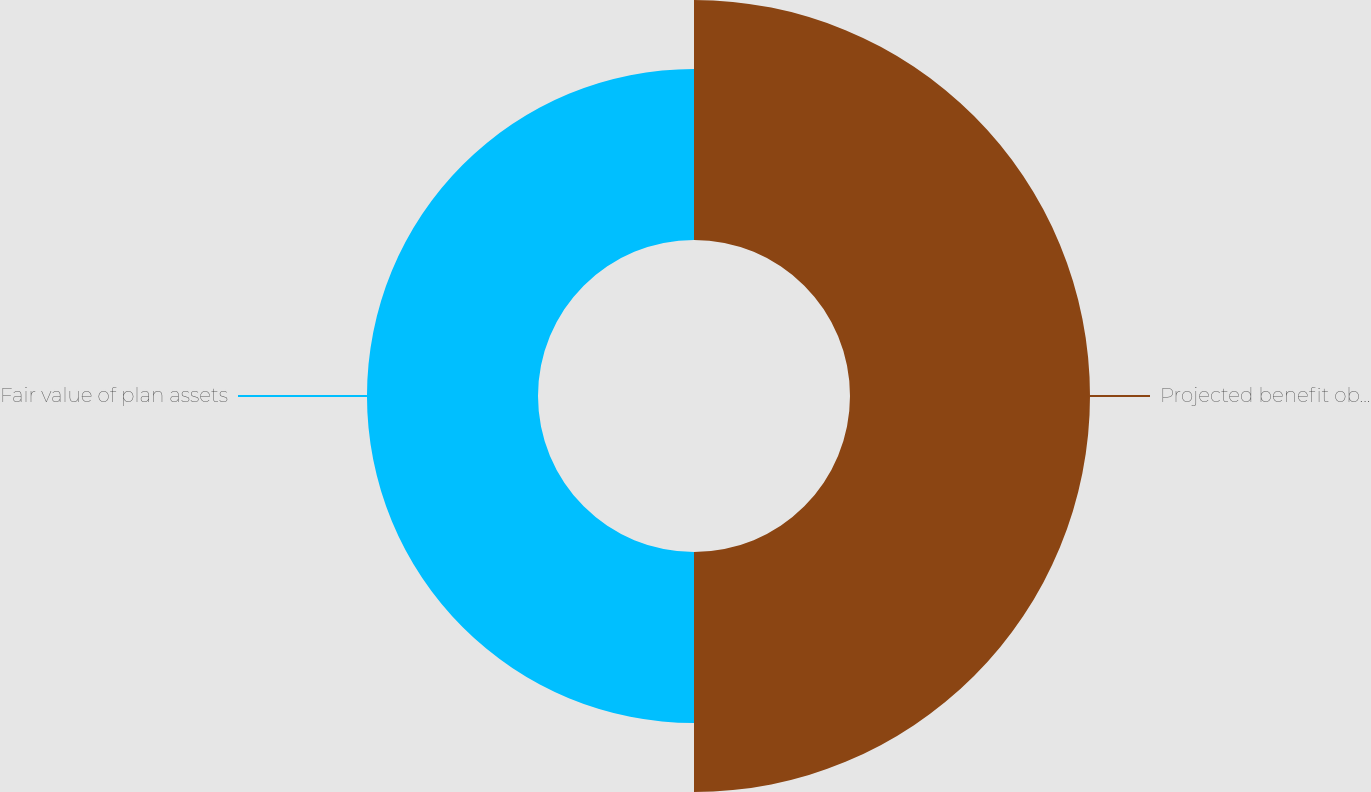<chart> <loc_0><loc_0><loc_500><loc_500><pie_chart><fcel>Projected benefit obligation<fcel>Fair value of plan assets<nl><fcel>58.39%<fcel>41.61%<nl></chart> 